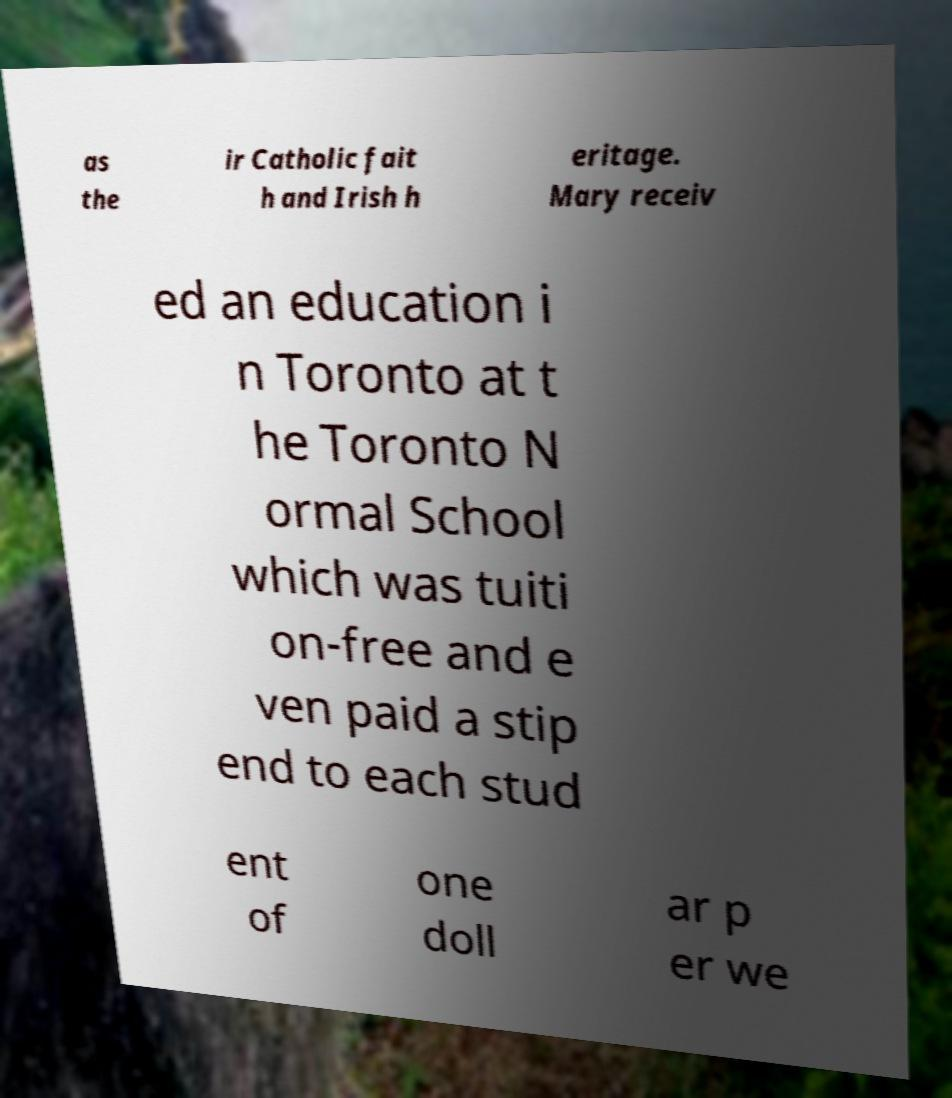I need the written content from this picture converted into text. Can you do that? as the ir Catholic fait h and Irish h eritage. Mary receiv ed an education i n Toronto at t he Toronto N ormal School which was tuiti on-free and e ven paid a stip end to each stud ent of one doll ar p er we 